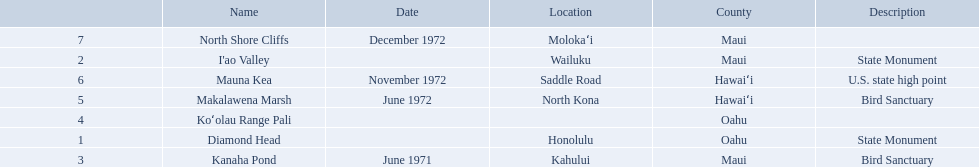Which national natural landmarks in hawaii are in oahu county? Diamond Head, Koʻolau Range Pali. Of these landmarks, which one is listed without a location? Koʻolau Range Pali. 